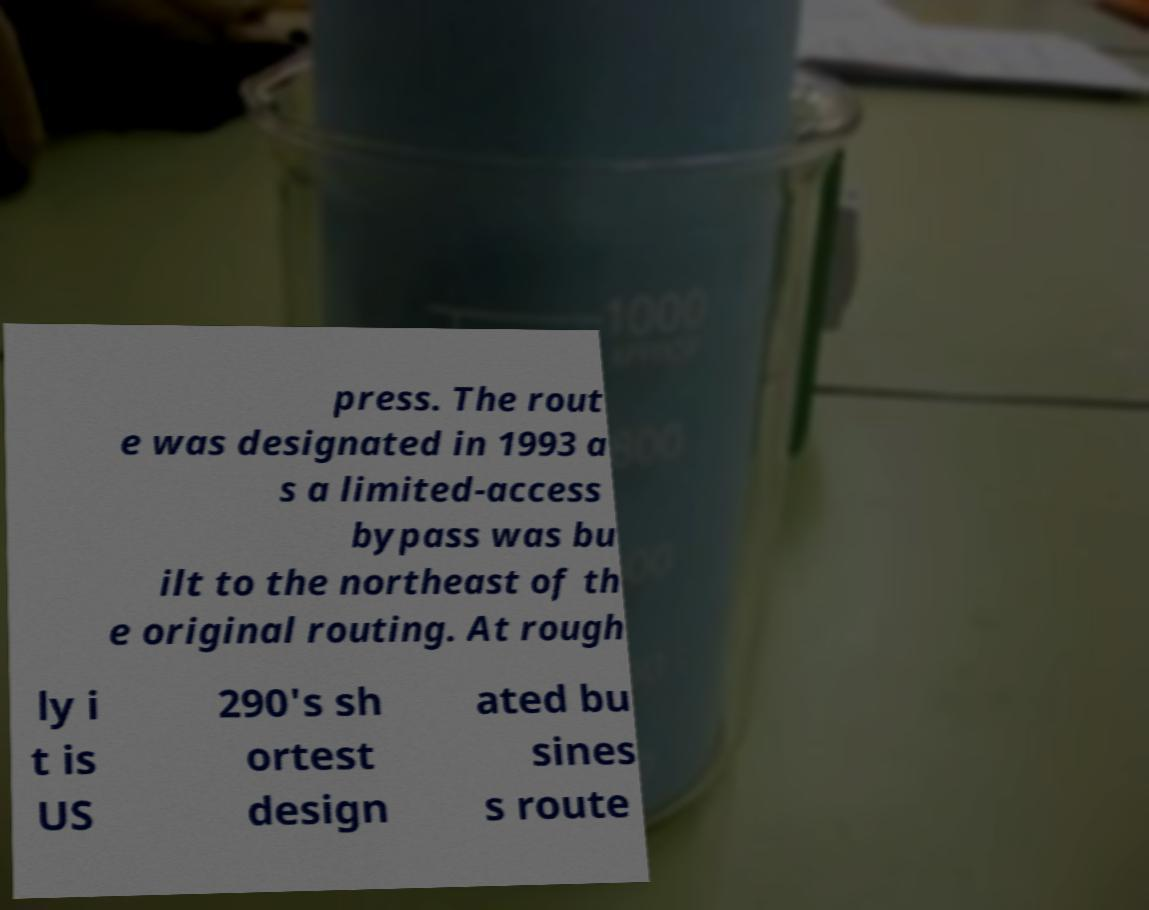Can you read and provide the text displayed in the image?This photo seems to have some interesting text. Can you extract and type it out for me? press. The rout e was designated in 1993 a s a limited-access bypass was bu ilt to the northeast of th e original routing. At rough ly i t is US 290's sh ortest design ated bu sines s route 